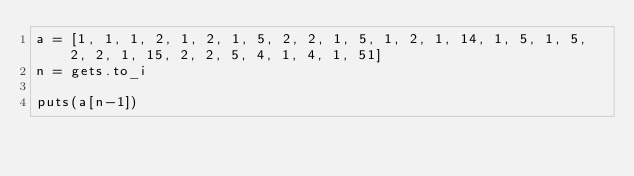<code> <loc_0><loc_0><loc_500><loc_500><_Ruby_>a = [1, 1, 1, 2, 1, 2, 1, 5, 2, 2, 1, 5, 1, 2, 1, 14, 1, 5, 1, 5, 2, 2, 1, 15, 2, 2, 5, 4, 1, 4, 1, 51]
n = gets.to_i

puts(a[n-1])</code> 